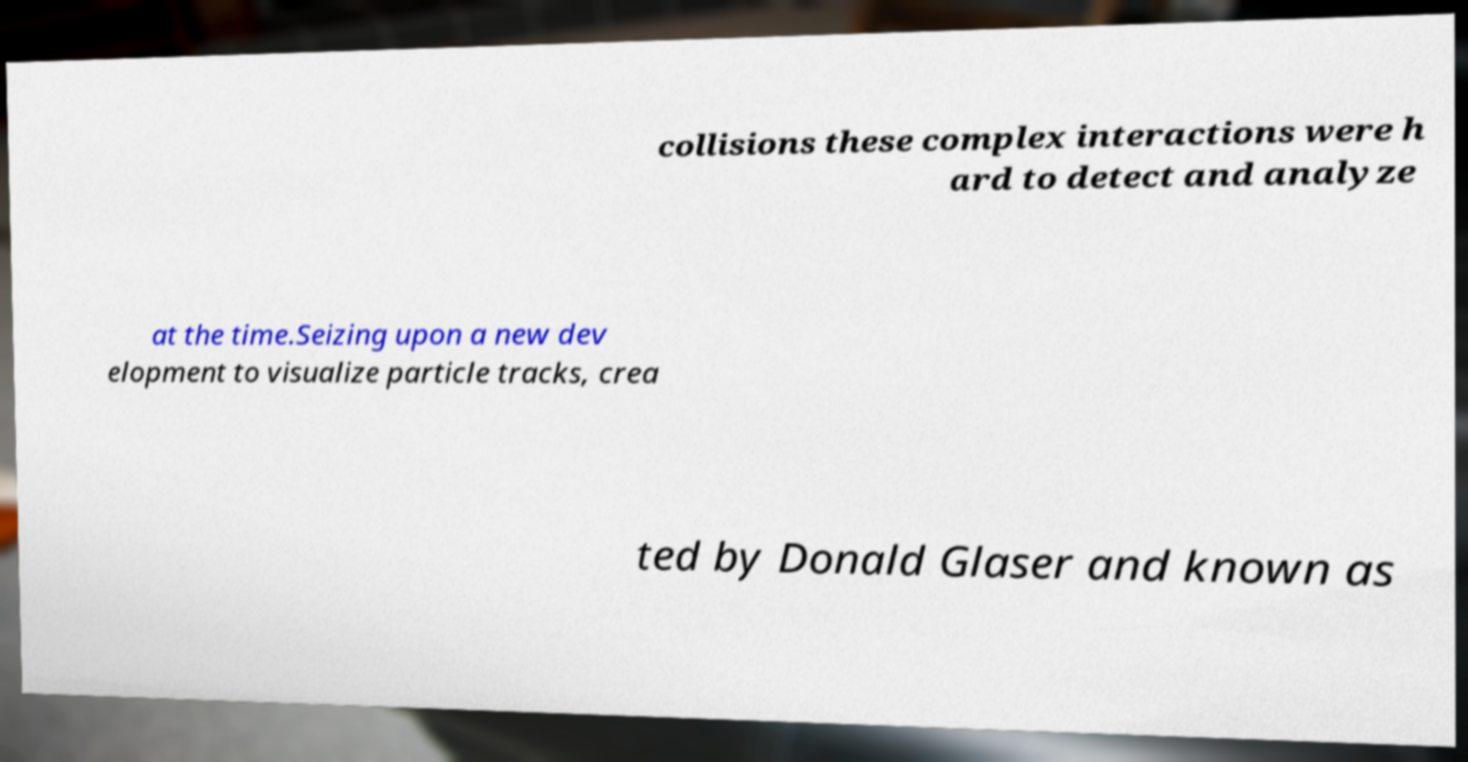Can you read and provide the text displayed in the image?This photo seems to have some interesting text. Can you extract and type it out for me? collisions these complex interactions were h ard to detect and analyze at the time.Seizing upon a new dev elopment to visualize particle tracks, crea ted by Donald Glaser and known as 